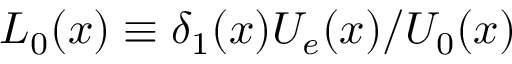<formula> <loc_0><loc_0><loc_500><loc_500>L _ { 0 } ( x ) \equiv \delta _ { 1 } ( x ) U _ { e } ( x ) / U _ { 0 } ( x )</formula> 